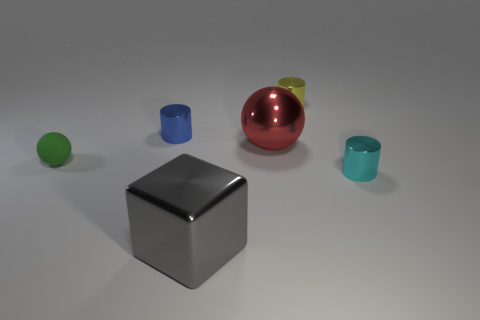Add 2 cubes. How many objects exist? 8 Subtract all cubes. How many objects are left? 5 Add 1 big balls. How many big balls are left? 2 Add 2 big shiny objects. How many big shiny objects exist? 4 Subtract 0 gray balls. How many objects are left? 6 Subtract all yellow metallic objects. Subtract all blue shiny objects. How many objects are left? 4 